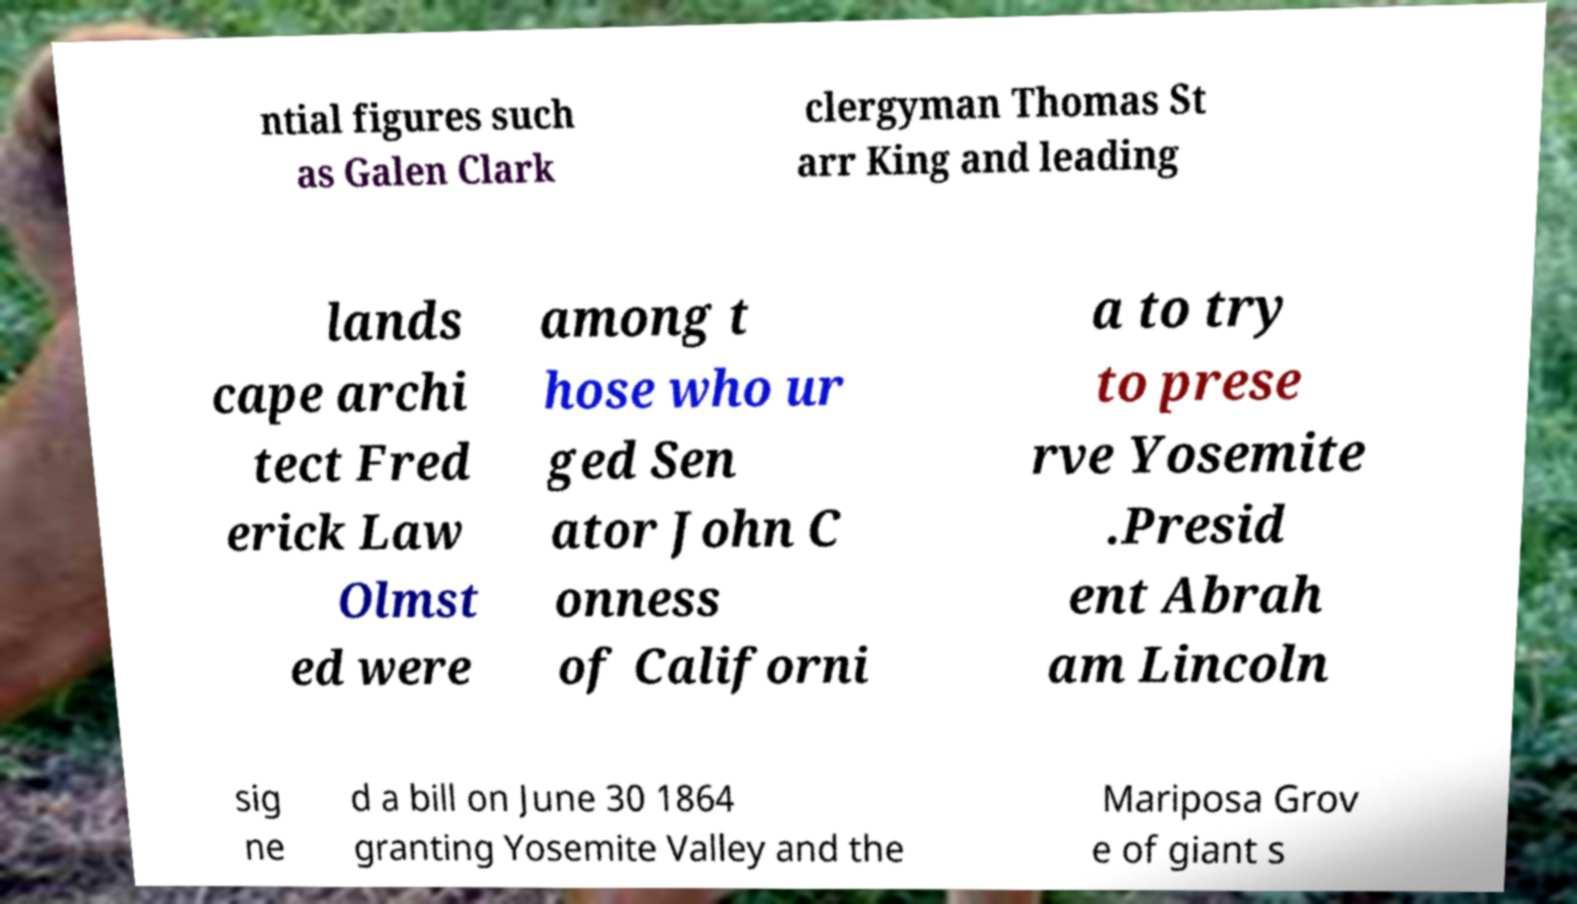Please identify and transcribe the text found in this image. ntial figures such as Galen Clark clergyman Thomas St arr King and leading lands cape archi tect Fred erick Law Olmst ed were among t hose who ur ged Sen ator John C onness of Californi a to try to prese rve Yosemite .Presid ent Abrah am Lincoln sig ne d a bill on June 30 1864 granting Yosemite Valley and the Mariposa Grov e of giant s 